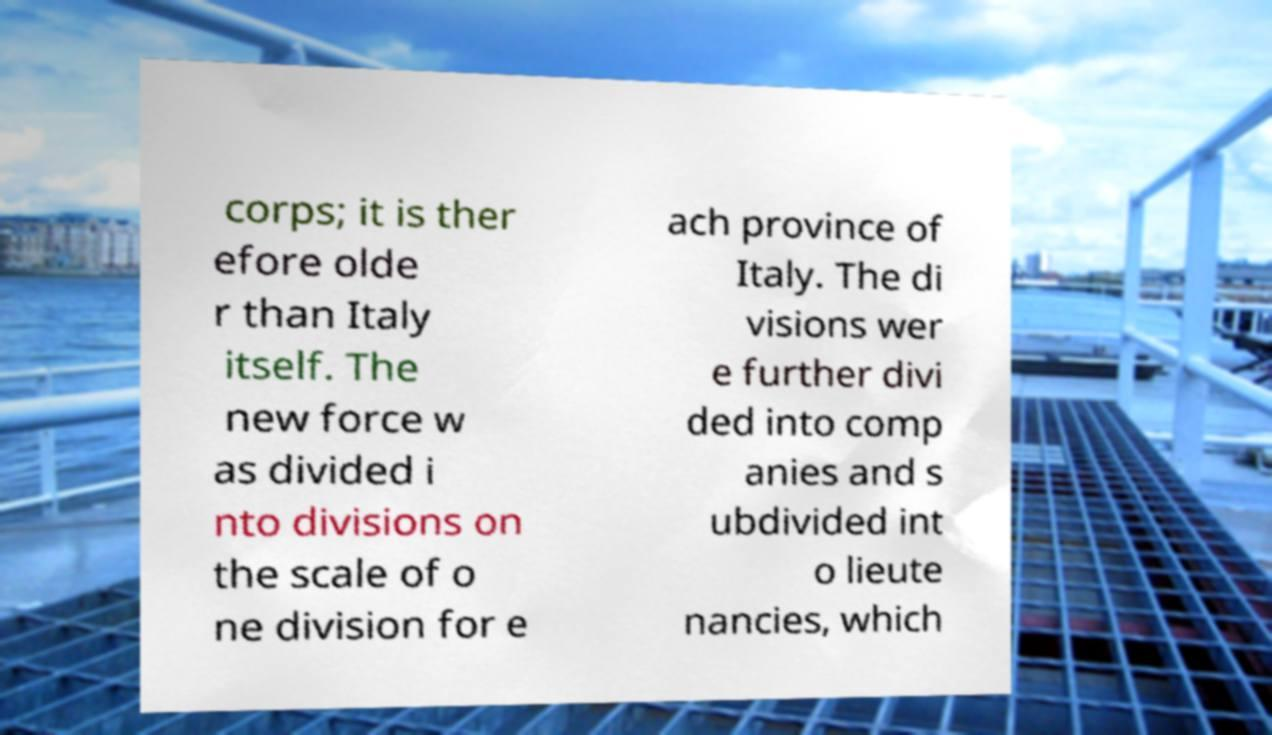Please identify and transcribe the text found in this image. corps; it is ther efore olde r than Italy itself. The new force w as divided i nto divisions on the scale of o ne division for e ach province of Italy. The di visions wer e further divi ded into comp anies and s ubdivided int o lieute nancies, which 